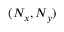<formula> <loc_0><loc_0><loc_500><loc_500>( N _ { x } , N _ { y } )</formula> 